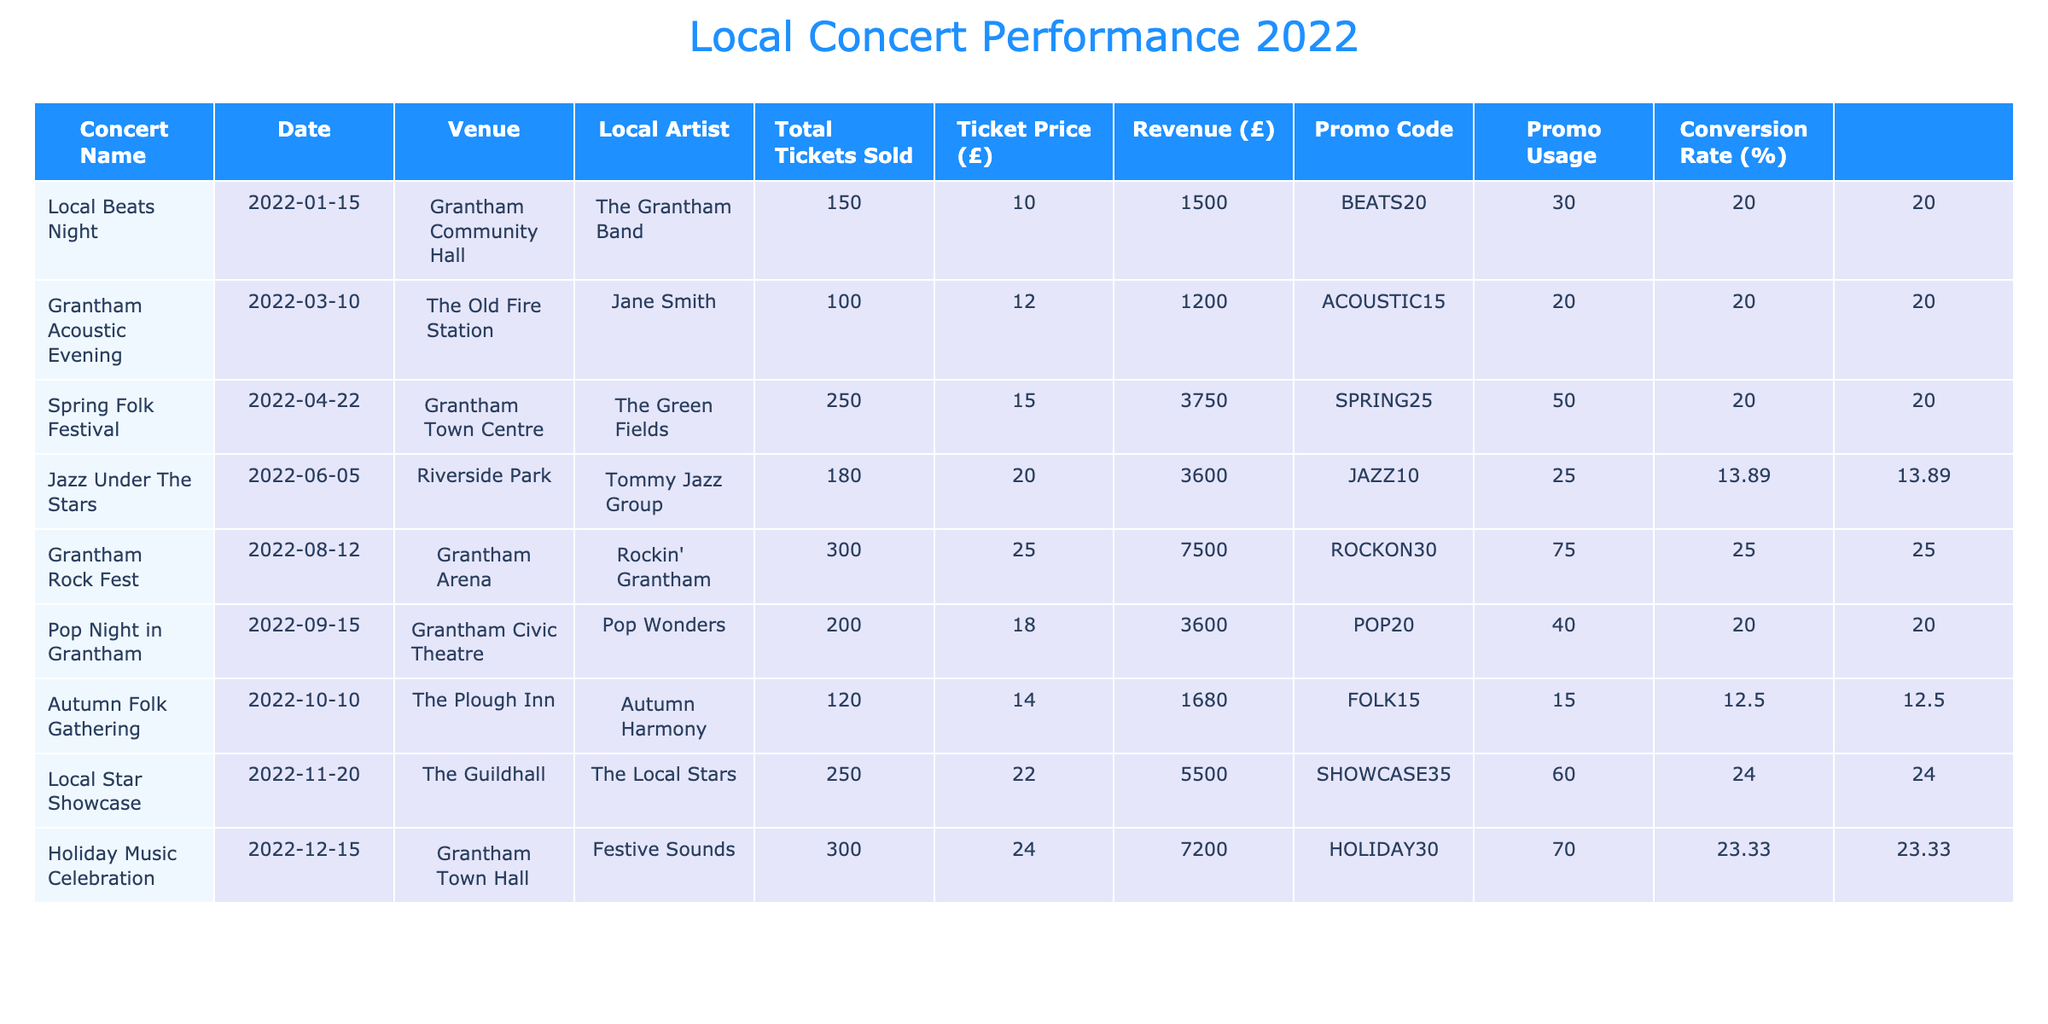What was the total revenue generated from the Grantham Rock Fest? The revenue for Grantham Rock Fest is listed in the Revenue column. From the table, it shows that the revenue generated was 7500.
Answer: 7500 Which concert had the highest ticket sales and how many tickets were sold? By comparing the Total Tickets Sold column for all concerts, Grantham Rock Fest shows the highest number of tickets sold, which is 300.
Answer: Grantham Rock Fest, 300 What is the average ticket price across all concerts? To calculate the average ticket price, sum all the Ticket Prices (10 + 12 + 15 + 20 + 25 + 18 + 14 + 22 + 24 = 150) and divide by the number of concerts (9). The average ticket price is 150/9 = 16.67.
Answer: 16.67 Did Jazz Under The Stars have a conversion rate greater than 15%? The conversion rate can be found in the Conversion Rate column. For Jazz Under The Stars, it is calculated as (25 / 180) * 100 = 13.89%. Since 13.89% is less than 15%, the answer is no.
Answer: No Which concert had the lowest promo usage percentage? To find the lowest promo usage percentage, we look for the minimum value in the Conversion Rate column. The lowest is for Autumn Folk Gathering at (15 / 120) * 100 = 12.5%, which is the smallest value compared to others.
Answer: Autumn Folk Gathering What is the total revenue generated from concerts with the promo code "HOLIDAY30"? The revenue for Holiday Music Celebration can be directly referenced from the Revenue column and is listed as 7200.
Answer: 7200 How many concerts had a ticket price greater than 20 pounds? By reviewing the Ticket Price column and counting the concerts with prices above 20, we find Grantham Rock Fest, Local Star Showcase, and Holiday Music Celebration, totaling 3 concerts.
Answer: 3 Which local artist sold the most tickets together for their concerts? We need to sum the Total Tickets Sold for each local artist. The Grantham Band (150) + Jane Smith (100) + The Green Fields (250) + Tommy Jazz Group (180) + Rockin' Grantham (300) + Pop Wonders (200) + Autumn Harmony (120) + The Local Stars (250) + Festive Sounds (300). The total for Rockin' Grantham is the highest at 300.
Answer: Rockin' Grantham, 300 Is there a concert that sold exactly 200 tickets? By checking the Total Tickets Sold column, it shows that Pop Night in Grantham sold exactly 200 tickets.
Answer: Yes 